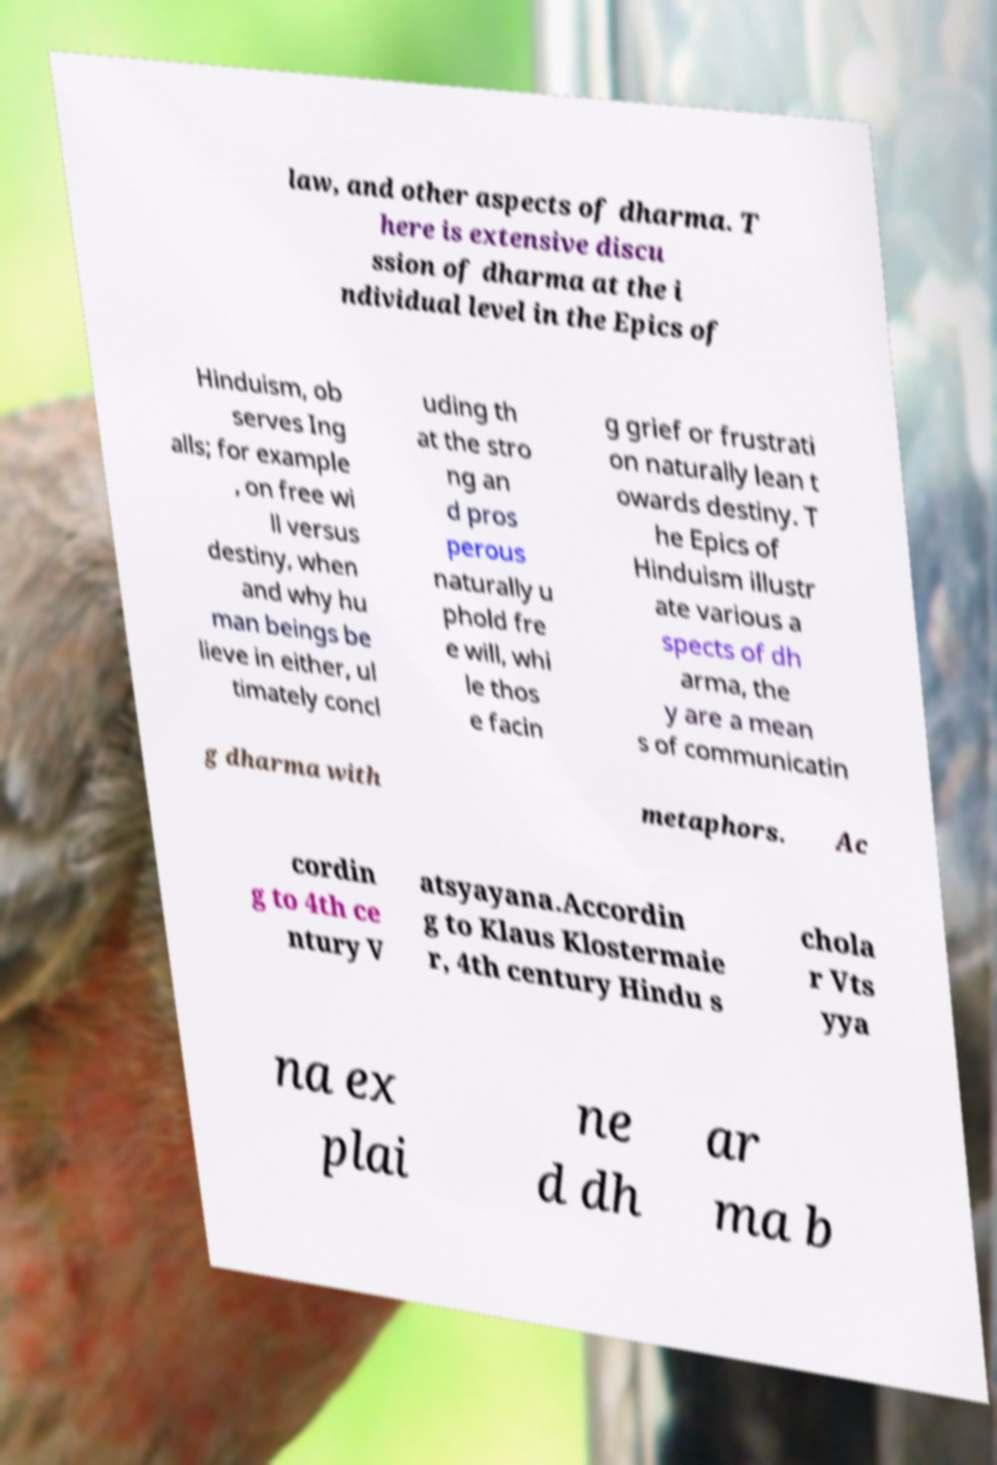Could you assist in decoding the text presented in this image and type it out clearly? law, and other aspects of dharma. T here is extensive discu ssion of dharma at the i ndividual level in the Epics of Hinduism, ob serves Ing alls; for example , on free wi ll versus destiny, when and why hu man beings be lieve in either, ul timately concl uding th at the stro ng an d pros perous naturally u phold fre e will, whi le thos e facin g grief or frustrati on naturally lean t owards destiny. T he Epics of Hinduism illustr ate various a spects of dh arma, the y are a mean s of communicatin g dharma with metaphors. Ac cordin g to 4th ce ntury V atsyayana.Accordin g to Klaus Klostermaie r, 4th century Hindu s chola r Vts yya na ex plai ne d dh ar ma b 